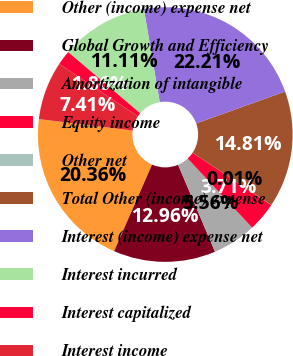Convert chart. <chart><loc_0><loc_0><loc_500><loc_500><pie_chart><fcel>Other (income) expense net<fcel>Global Growth and Efficiency<fcel>Amortization of intangible<fcel>Equity income<fcel>Other net<fcel>Total Other (income) expense<fcel>Interest (income) expense net<fcel>Interest incurred<fcel>Interest capitalized<fcel>Interest income<nl><fcel>20.36%<fcel>12.96%<fcel>5.56%<fcel>3.71%<fcel>0.01%<fcel>14.81%<fcel>22.21%<fcel>11.11%<fcel>1.86%<fcel>7.41%<nl></chart> 